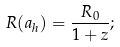<formula> <loc_0><loc_0><loc_500><loc_500>R ( a _ { h } ) = \frac { R _ { 0 } } { 1 + z } ;</formula> 